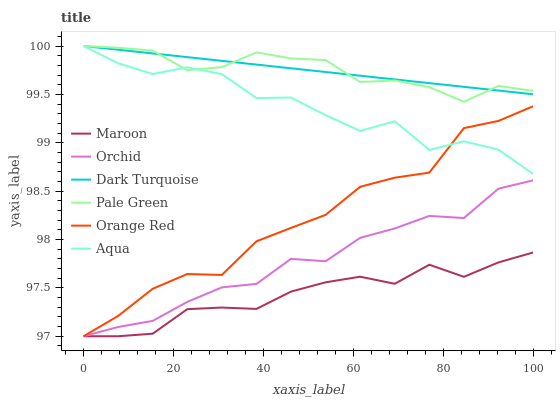Does Maroon have the minimum area under the curve?
Answer yes or no. Yes. Does Dark Turquoise have the maximum area under the curve?
Answer yes or no. Yes. Does Aqua have the minimum area under the curve?
Answer yes or no. No. Does Aqua have the maximum area under the curve?
Answer yes or no. No. Is Dark Turquoise the smoothest?
Answer yes or no. Yes. Is Aqua the roughest?
Answer yes or no. Yes. Is Maroon the smoothest?
Answer yes or no. No. Is Maroon the roughest?
Answer yes or no. No. Does Aqua have the lowest value?
Answer yes or no. No. Does Pale Green have the highest value?
Answer yes or no. Yes. Does Maroon have the highest value?
Answer yes or no. No. Is Maroon less than Pale Green?
Answer yes or no. Yes. Is Aqua greater than Maroon?
Answer yes or no. Yes. Does Maroon intersect Orchid?
Answer yes or no. Yes. Is Maroon less than Orchid?
Answer yes or no. No. Is Maroon greater than Orchid?
Answer yes or no. No. Does Maroon intersect Pale Green?
Answer yes or no. No. 